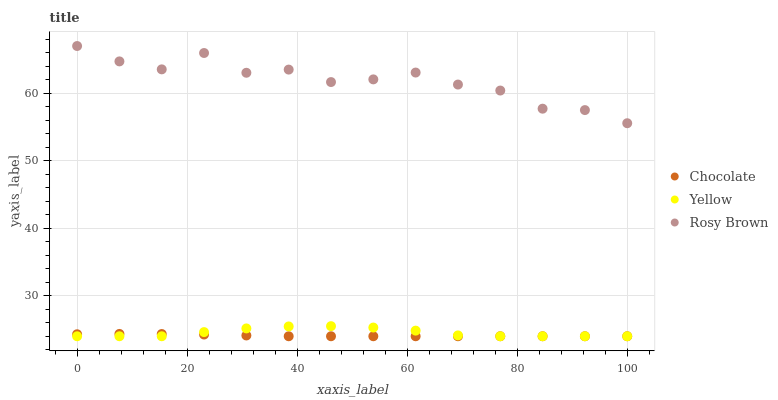Does Chocolate have the minimum area under the curve?
Answer yes or no. Yes. Does Rosy Brown have the maximum area under the curve?
Answer yes or no. Yes. Does Yellow have the minimum area under the curve?
Answer yes or no. No. Does Yellow have the maximum area under the curve?
Answer yes or no. No. Is Chocolate the smoothest?
Answer yes or no. Yes. Is Rosy Brown the roughest?
Answer yes or no. Yes. Is Yellow the smoothest?
Answer yes or no. No. Is Yellow the roughest?
Answer yes or no. No. Does Yellow have the lowest value?
Answer yes or no. Yes. Does Rosy Brown have the highest value?
Answer yes or no. Yes. Does Yellow have the highest value?
Answer yes or no. No. Is Chocolate less than Rosy Brown?
Answer yes or no. Yes. Is Rosy Brown greater than Chocolate?
Answer yes or no. Yes. Does Chocolate intersect Yellow?
Answer yes or no. Yes. Is Chocolate less than Yellow?
Answer yes or no. No. Is Chocolate greater than Yellow?
Answer yes or no. No. Does Chocolate intersect Rosy Brown?
Answer yes or no. No. 